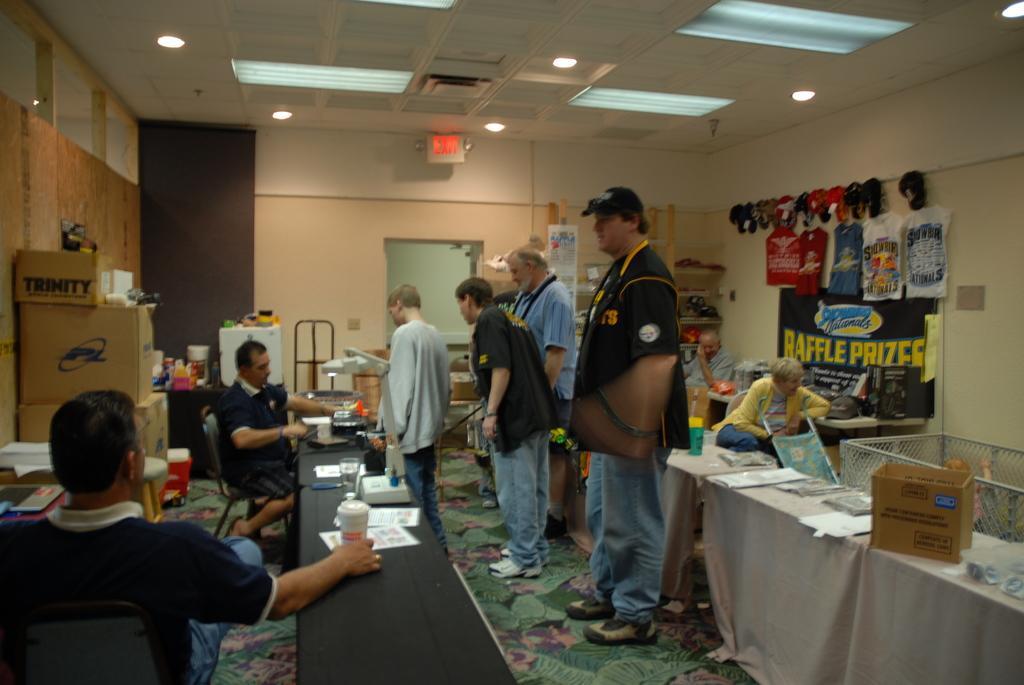Describe this image in one or two sentences. On the left side 2 men are sitting on the stools. In the middle few persons are standing, at the top there are ceiling lights. 